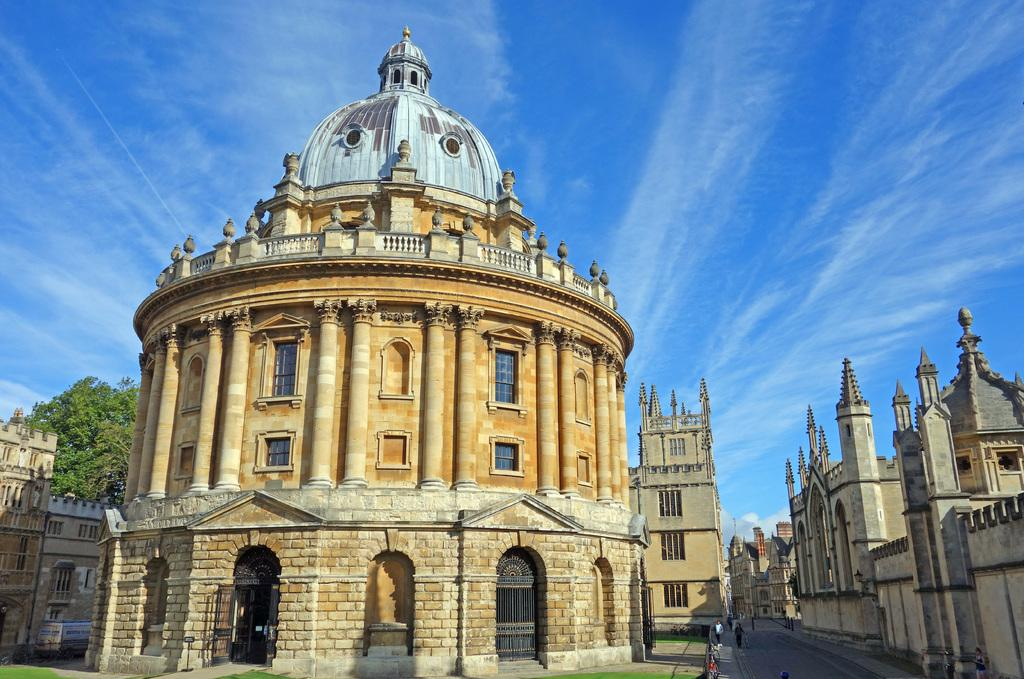What type of structures can be seen in the image? There are many buildings in the image. What architectural features are visible on the buildings? Walls and windows are visible in the image. What type of vegetation is present in the image? There is a tree and grass visible in the image. Where are the people located in the image? The people are at the bottom of the image. What is the ground surface like at the bottom of the image? There is a road and grass at the bottom of the image. What can be seen in the background of the image? The sky is visible in the background of the image. How many horses are visible in the image? There are no horses present in the image. What route do the people take to measure the distance between the buildings? The image does not show any measuring or routes; it only shows buildings, walls, windows, a tree, grass, people, a road, and the sky. 